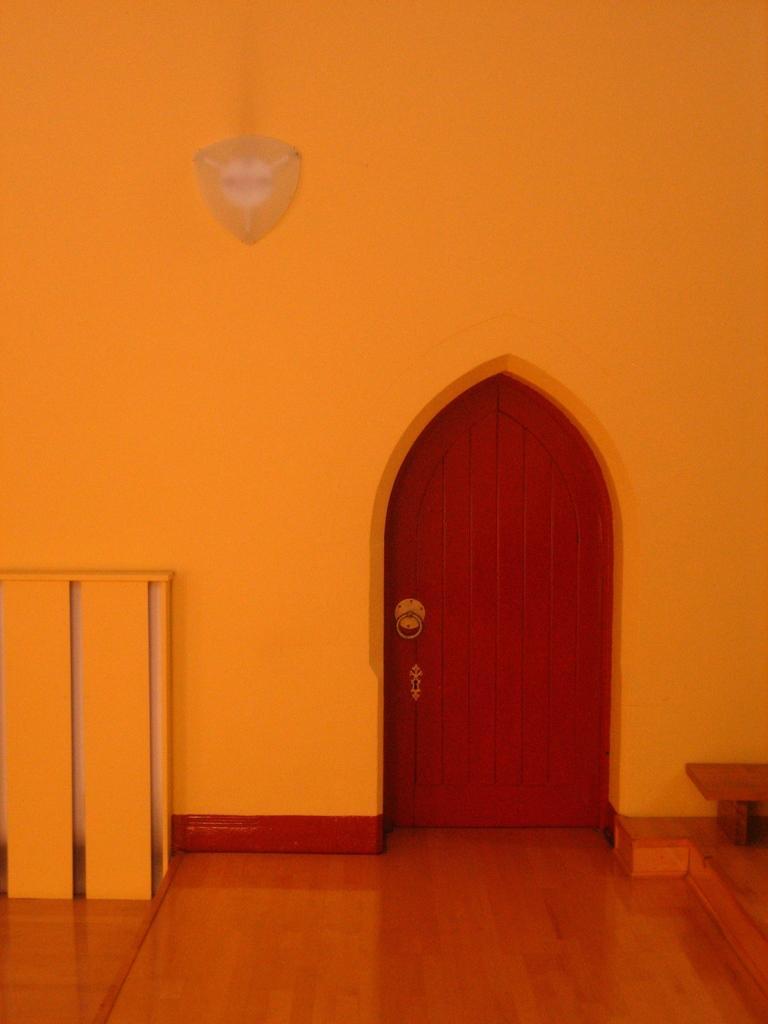How would you summarize this image in a sentence or two? The picture consists of a door, bench, wall and an object. In the foreground it is well. 